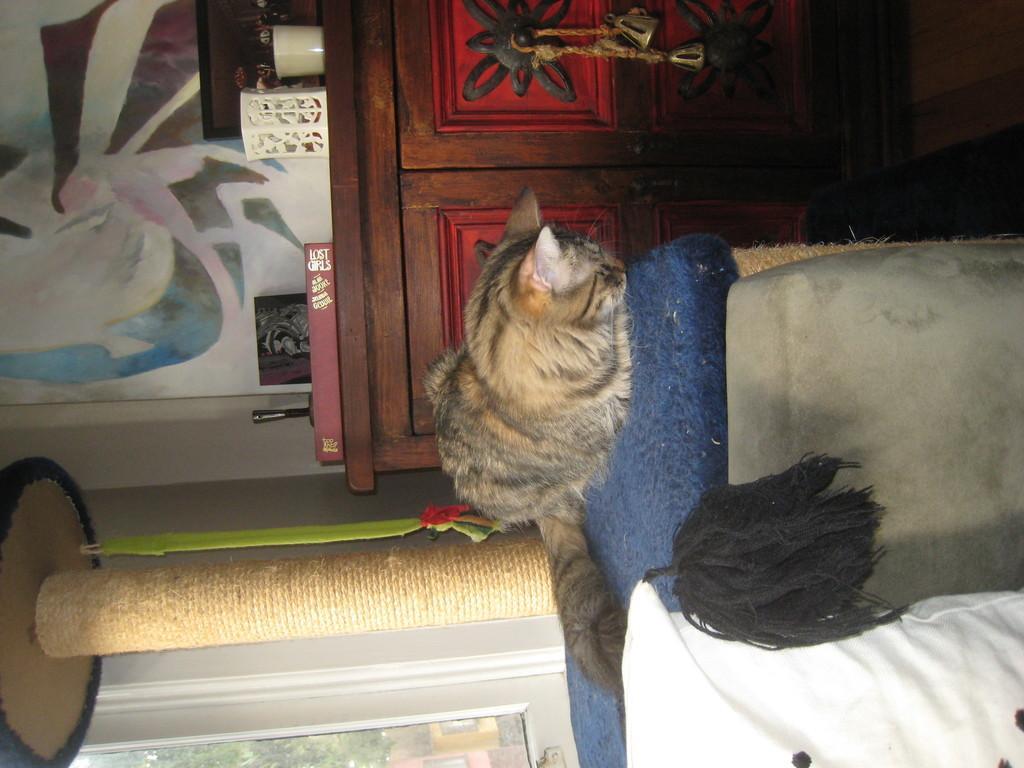Describe this image in one or two sentences. This is the picture of a room. in this image there is a cat sitting on the sofa and there is a pillow on the sofa. At the back there is window and there is a lamp, book, cup and frames on the table and there is a painting on the wall. 